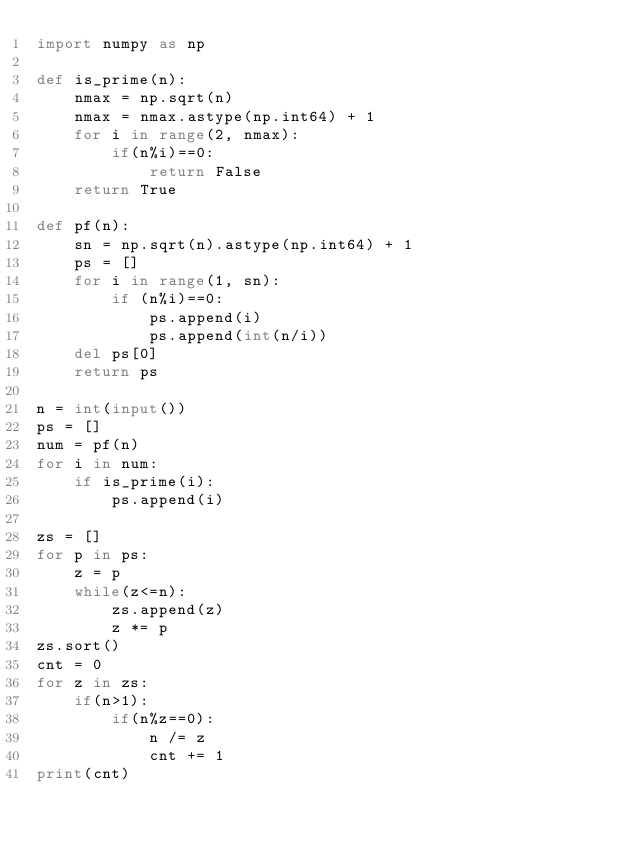Convert code to text. <code><loc_0><loc_0><loc_500><loc_500><_Python_>import numpy as np

def is_prime(n):
    nmax = np.sqrt(n)
    nmax = nmax.astype(np.int64) + 1
    for i in range(2, nmax):
        if(n%i)==0:
            return False
    return True

def pf(n):
    sn = np.sqrt(n).astype(np.int64) + 1
    ps = []
    for i in range(1, sn):
        if (n%i)==0:
            ps.append(i)
            ps.append(int(n/i))
    del ps[0]
    return ps        

n = int(input())
ps = []
num = pf(n)
for i in num:
    if is_prime(i):
        ps.append(i)
        
zs = []        
for p in ps:
    z = p
    while(z<=n):
        zs.append(z)
        z *= p
zs.sort()
cnt = 0
for z in zs:
    if(n>1):
        if(n%z==0):
            n /= z
            cnt += 1
print(cnt)</code> 